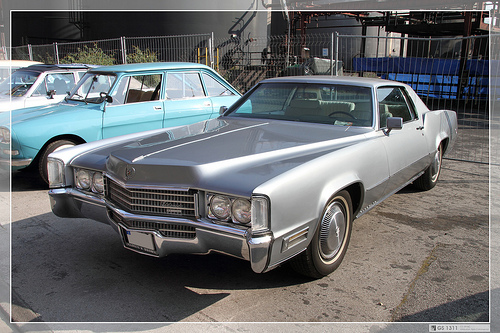<image>
Is the car on the car? No. The car is not positioned on the car. They may be near each other, but the car is not supported by or resting on top of the car. 